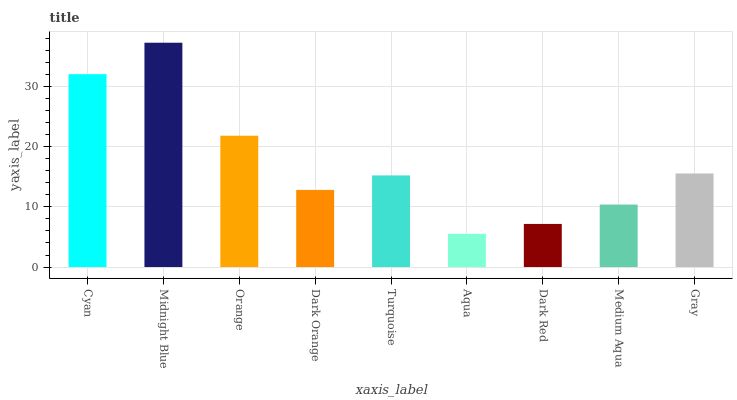Is Aqua the minimum?
Answer yes or no. Yes. Is Midnight Blue the maximum?
Answer yes or no. Yes. Is Orange the minimum?
Answer yes or no. No. Is Orange the maximum?
Answer yes or no. No. Is Midnight Blue greater than Orange?
Answer yes or no. Yes. Is Orange less than Midnight Blue?
Answer yes or no. Yes. Is Orange greater than Midnight Blue?
Answer yes or no. No. Is Midnight Blue less than Orange?
Answer yes or no. No. Is Turquoise the high median?
Answer yes or no. Yes. Is Turquoise the low median?
Answer yes or no. Yes. Is Aqua the high median?
Answer yes or no. No. Is Cyan the low median?
Answer yes or no. No. 